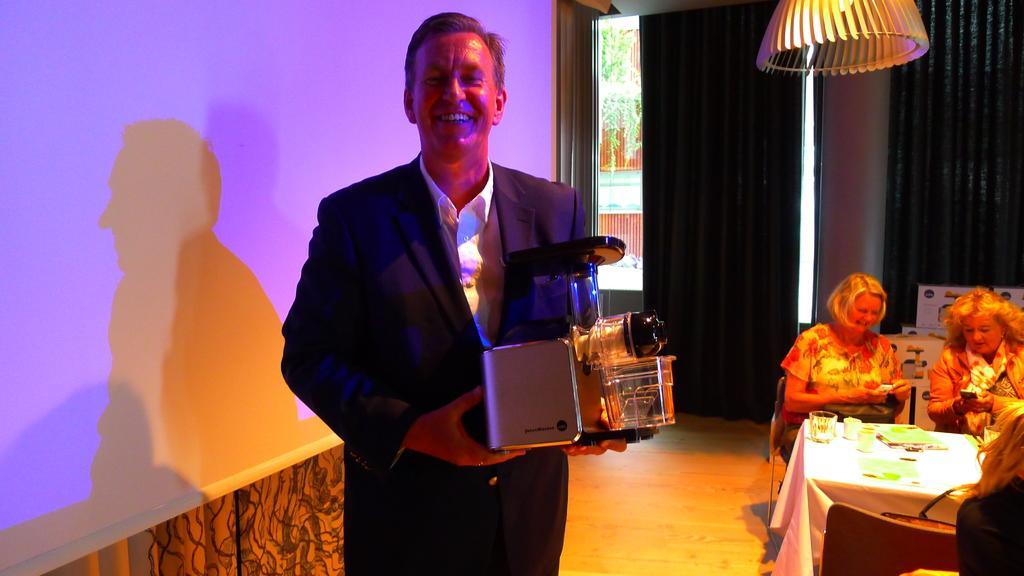Could you give a brief overview of what you see in this image? This picture is clicked inside the room. There is a man who is standing in front of the picture, is wearing a black blazer and is carrying machine in his hand and he is smiling. On the right bottom of the picture, we see two women sitting on chair, both of them holding mobile phones in their hands. In front of them, we see a table on which glass, cup and book are placed. Behind them, we see a wall which is brown in color and beside that, we see a window from which we see a red building and tree. 